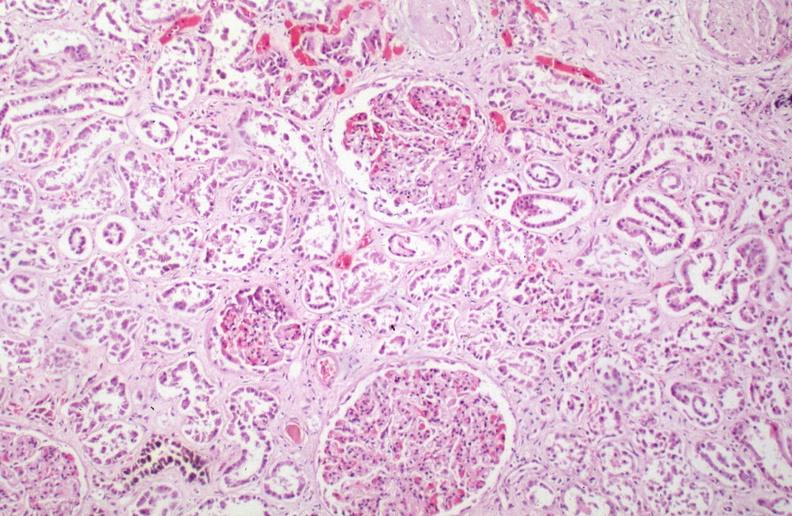what does this image show?
Answer the question using a single word or phrase. Kidney 